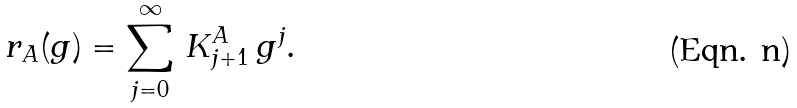<formula> <loc_0><loc_0><loc_500><loc_500>r _ { A } ( g ) = \sum _ { j = 0 } ^ { \infty } \, K _ { j + 1 } ^ { A } \, g ^ { j } .</formula> 